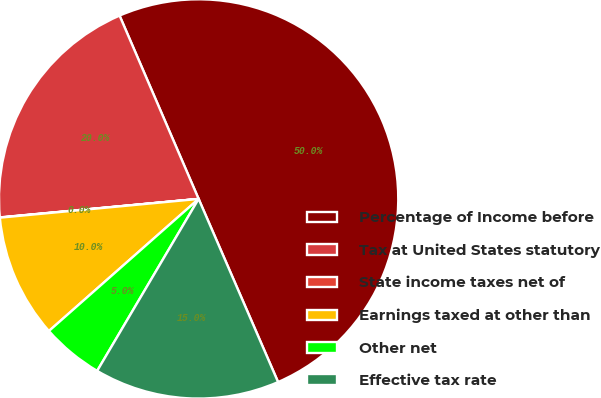<chart> <loc_0><loc_0><loc_500><loc_500><pie_chart><fcel>Percentage of Income before<fcel>Tax at United States statutory<fcel>State income taxes net of<fcel>Earnings taxed at other than<fcel>Other net<fcel>Effective tax rate<nl><fcel>49.97%<fcel>20.0%<fcel>0.02%<fcel>10.01%<fcel>5.01%<fcel>15.0%<nl></chart> 